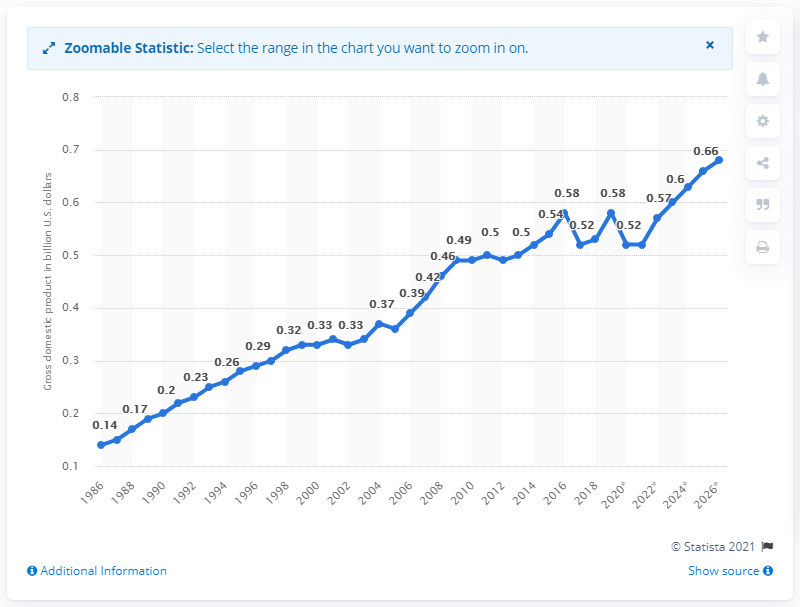Mention a couple of crucial points in this snapshot. In 2018, the gross domestic product (GDP) of Dominica was approximately 0.53 billion dollars. 